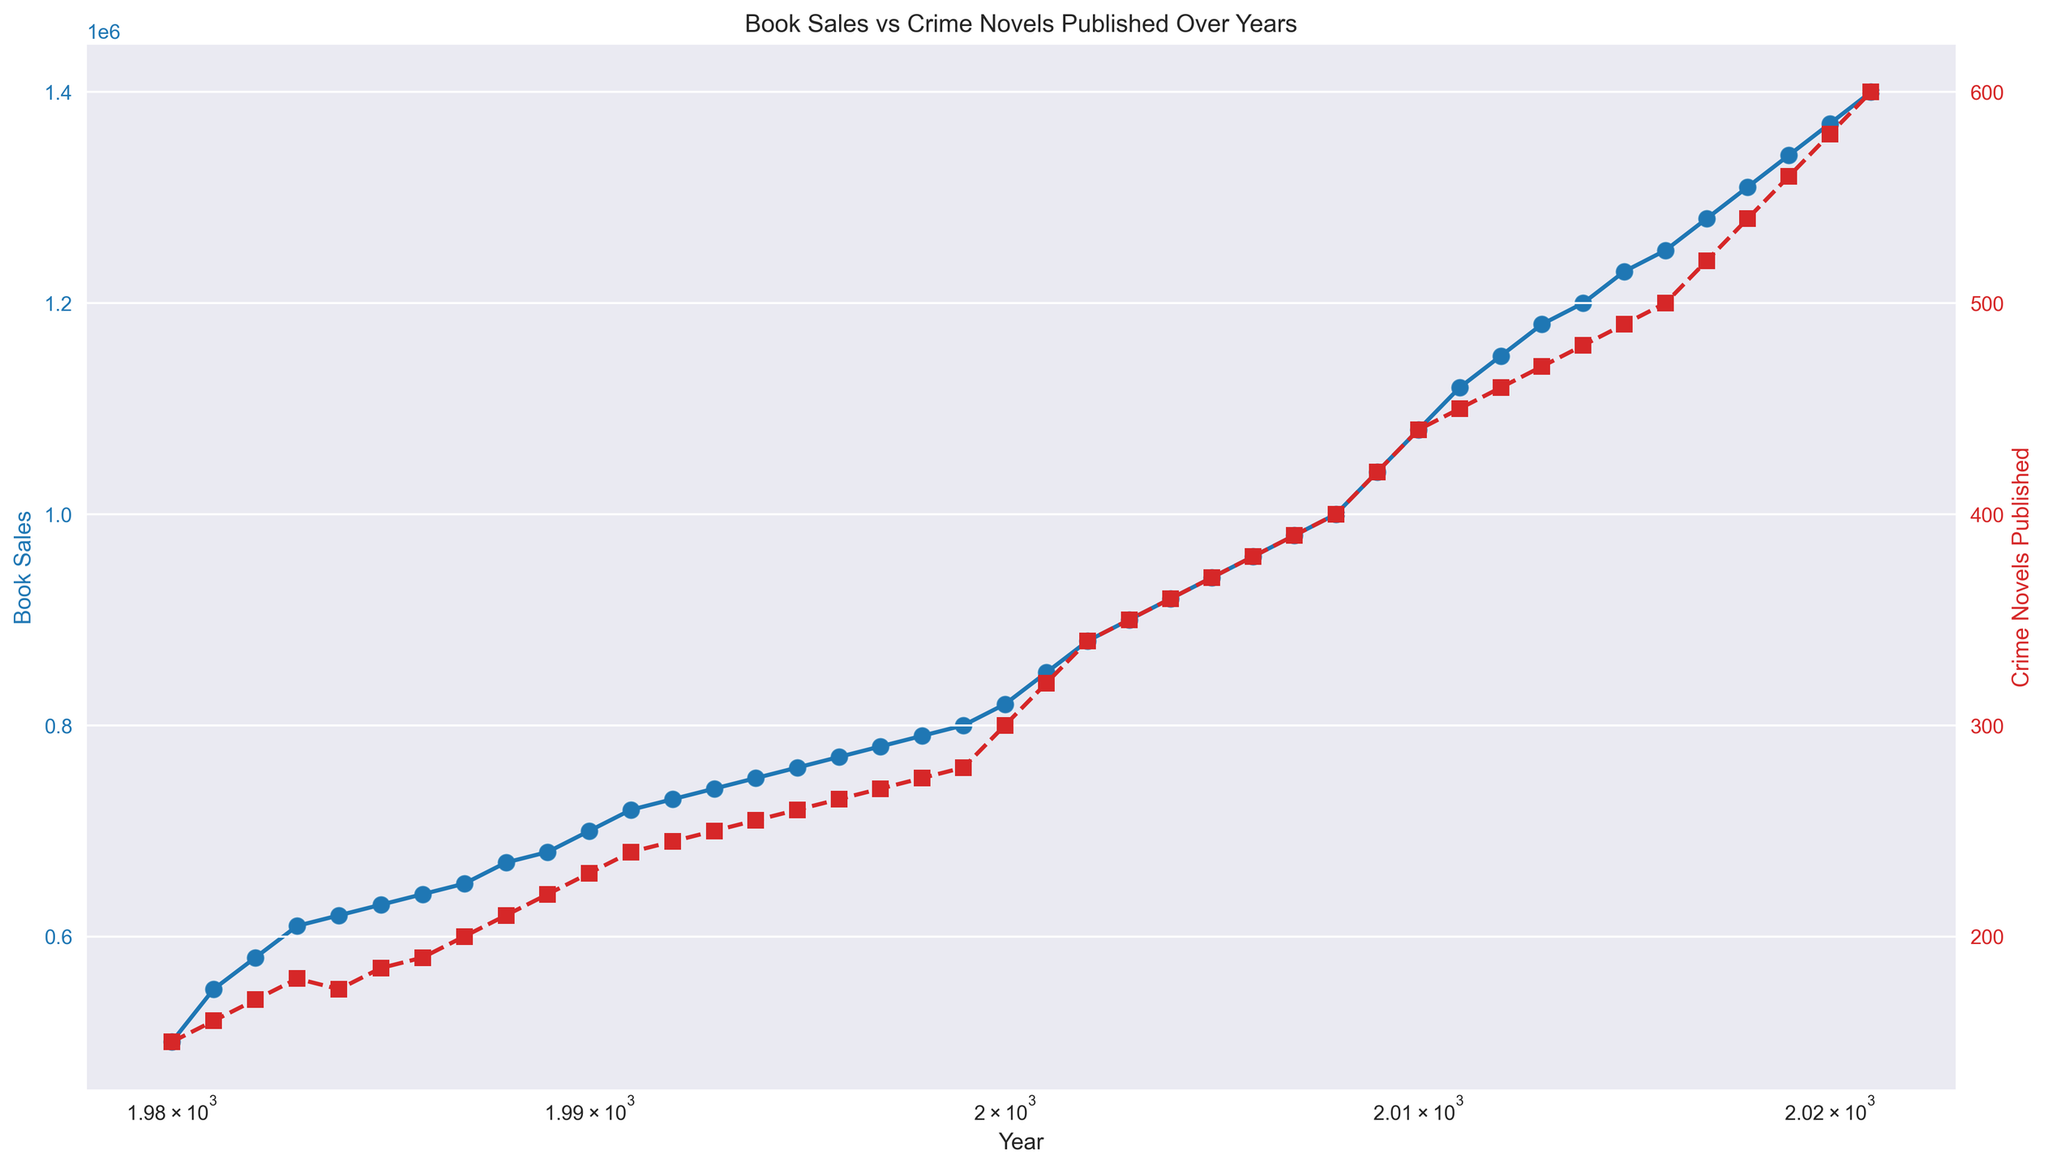When did book sales first reach 1 million? Look at the book sales curve (blue line) and find the first year where the sales pass the 1 million mark. It occurs in 2008.
Answer: 2008 Compare the number of crime novels published in 2010 and 2021. Which year had more? Observe the red line or points at the years 2010 and 2021. In 2010, 440 crime novels were published, and in 2021, 600 crime novels were published. Therefore, 2021 had more.
Answer: 2021 What is the trend in book sales from 1980 to 2021? Following the blue line from 1980 to 2021 shows a generally consistent upward trend in book sales, indicating continuous growth over the years.
Answer: Upward trend By how much did book sales increase from 2000 to 2021? Check the book sales figures in 2000 (820,000) and 2021 (1,400,000). Subtract the 2000 figure from the 2021 figure: 1,400,000 - 820,000 = 580,000.
Answer: 580,000 How do the trends in book sales and crime novels published compare over time? Both book sales (blue line) and the number of crime novels published (red line) show an upward trend over time, indicating a positive correlation between the two variables.
Answer: Positive correlation In which year did crime novels published see the highest jump? The red line slopes more sharply between 2000 and 2001 compared to other years, indicating the highest increase in crime novels published between these years.
Answer: 2000 to 2001 What is the average number of crime novels published per year from 2000 to 2010? Add the number of crime novels published each year from 2000 to 2010 and divide the sum by the number of years (11). Calculation: (300 + 320 + 340 + 350 + 360 + 370 + 380 + 390 + 400 + 420 + 440) / 11 = 370
Answer: 370 What is the color representing book sales? The blue line and points denote book sales, as seen in the plot.
Answer: Blue In which year did book sales and the number of crime novels published both pass a significant milestone together? Both the blue and red lines show significant milestones around the year 2000 when book sales approached 820,000, and crime novels published reached 300.
Answer: 2000 What is the logscaled x-axis used for in this plot? The logscaled x-axis is used to display the range of years in a manner that can better elucidate trends and comparisons over time, especially when spanning several decades.
Answer: To display the range of years effectively 